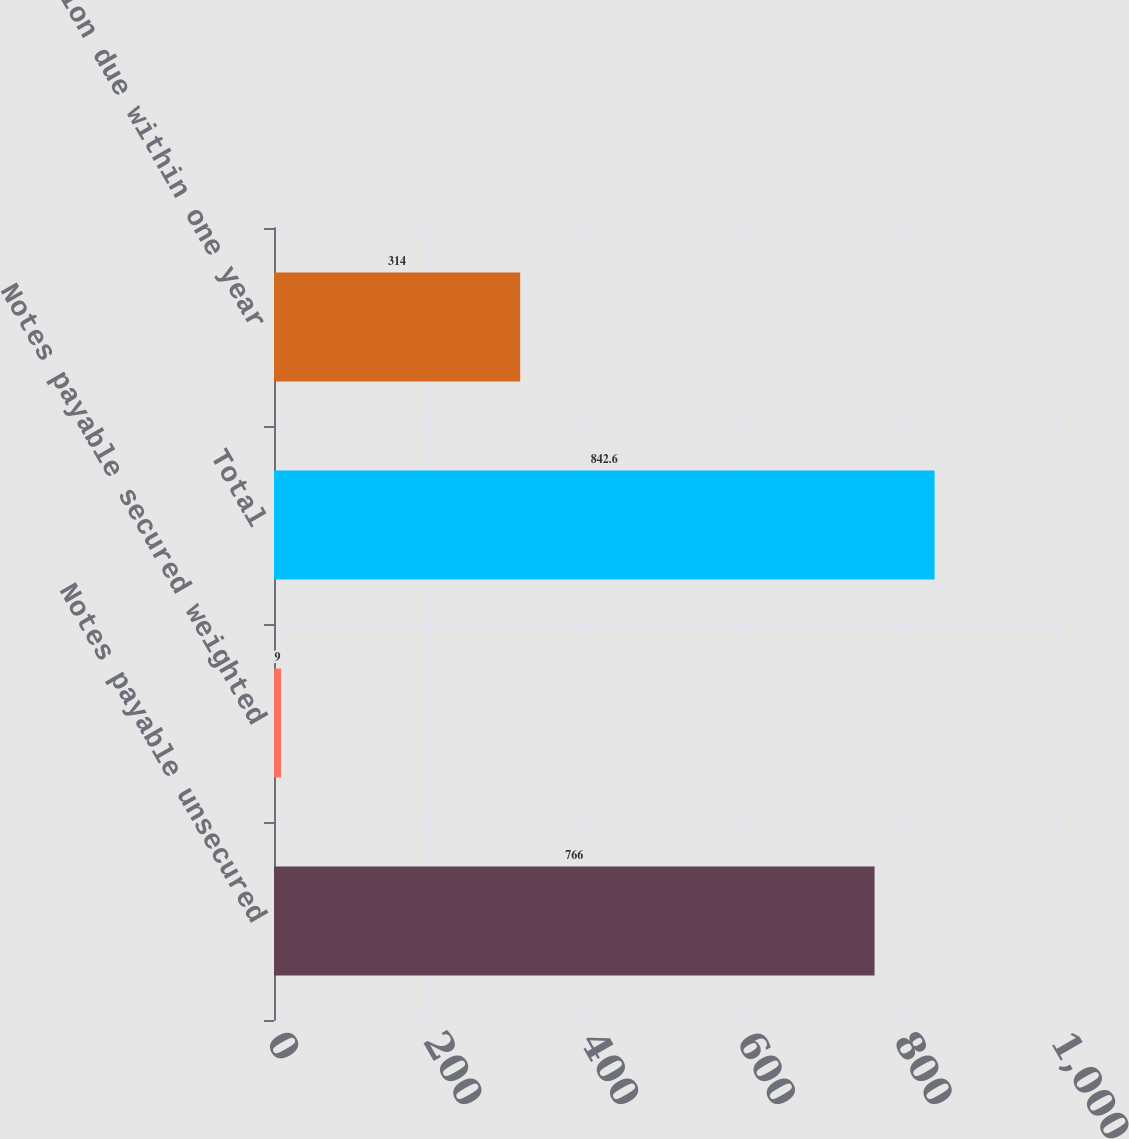Convert chart. <chart><loc_0><loc_0><loc_500><loc_500><bar_chart><fcel>Notes payable unsecured<fcel>Notes payable secured weighted<fcel>Total<fcel>Portion due within one year<nl><fcel>766<fcel>9<fcel>842.6<fcel>314<nl></chart> 